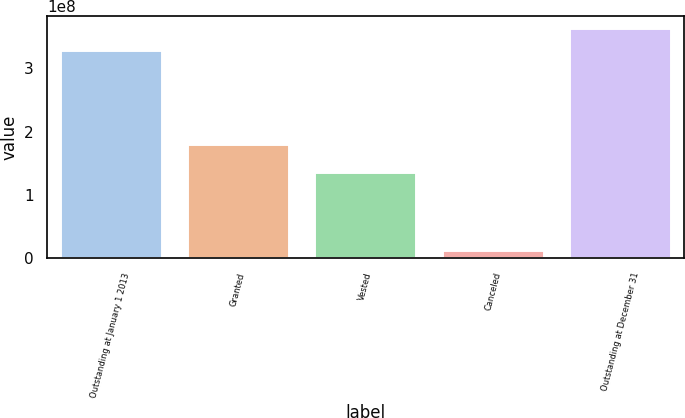Convert chart. <chart><loc_0><loc_0><loc_500><loc_500><bar_chart><fcel>Outstanding at January 1 2013<fcel>Granted<fcel>Vested<fcel>Canceled<fcel>Outstanding at December 31<nl><fcel>3.29556e+08<fcel>1.81167e+08<fcel>1.37125e+08<fcel>1.3669e+07<fcel>3.64182e+08<nl></chart> 